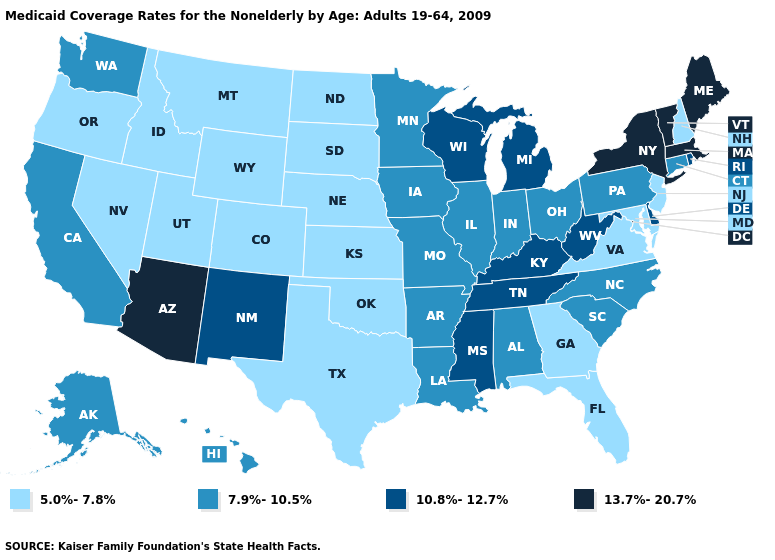What is the highest value in the USA?
Keep it brief. 13.7%-20.7%. Does Rhode Island have the same value as Kentucky?
Write a very short answer. Yes. Name the states that have a value in the range 7.9%-10.5%?
Keep it brief. Alabama, Alaska, Arkansas, California, Connecticut, Hawaii, Illinois, Indiana, Iowa, Louisiana, Minnesota, Missouri, North Carolina, Ohio, Pennsylvania, South Carolina, Washington. What is the value of Georgia?
Answer briefly. 5.0%-7.8%. What is the highest value in the USA?
Answer briefly. 13.7%-20.7%. Among the states that border Michigan , does Ohio have the highest value?
Write a very short answer. No. Which states have the lowest value in the USA?
Keep it brief. Colorado, Florida, Georgia, Idaho, Kansas, Maryland, Montana, Nebraska, Nevada, New Hampshire, New Jersey, North Dakota, Oklahoma, Oregon, South Dakota, Texas, Utah, Virginia, Wyoming. Which states hav the highest value in the West?
Answer briefly. Arizona. What is the value of Minnesota?
Write a very short answer. 7.9%-10.5%. What is the lowest value in the USA?
Concise answer only. 5.0%-7.8%. What is the highest value in the USA?
Answer briefly. 13.7%-20.7%. Does Illinois have the lowest value in the MidWest?
Answer briefly. No. What is the value of Connecticut?
Answer briefly. 7.9%-10.5%. What is the value of Kansas?
Short answer required. 5.0%-7.8%. Does Pennsylvania have a higher value than Illinois?
Be succinct. No. 